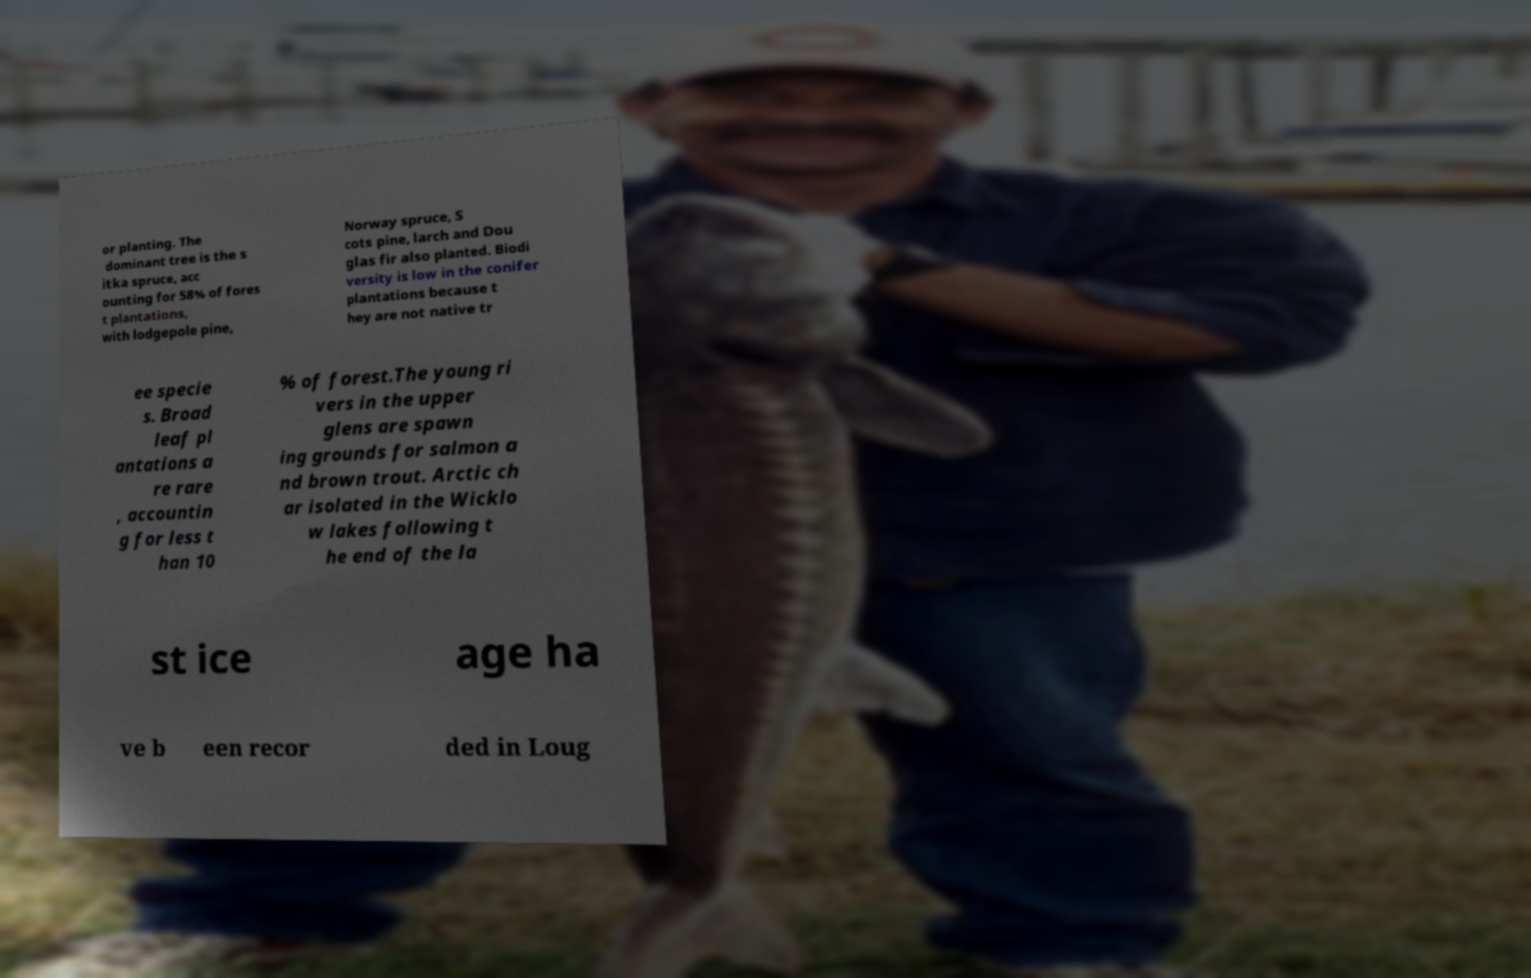Can you accurately transcribe the text from the provided image for me? or planting. The dominant tree is the s itka spruce, acc ounting for 58% of fores t plantations, with lodgepole pine, Norway spruce, S cots pine, larch and Dou glas fir also planted. Biodi versity is low in the conifer plantations because t hey are not native tr ee specie s. Broad leaf pl antations a re rare , accountin g for less t han 10 % of forest.The young ri vers in the upper glens are spawn ing grounds for salmon a nd brown trout. Arctic ch ar isolated in the Wicklo w lakes following t he end of the la st ice age ha ve b een recor ded in Loug 